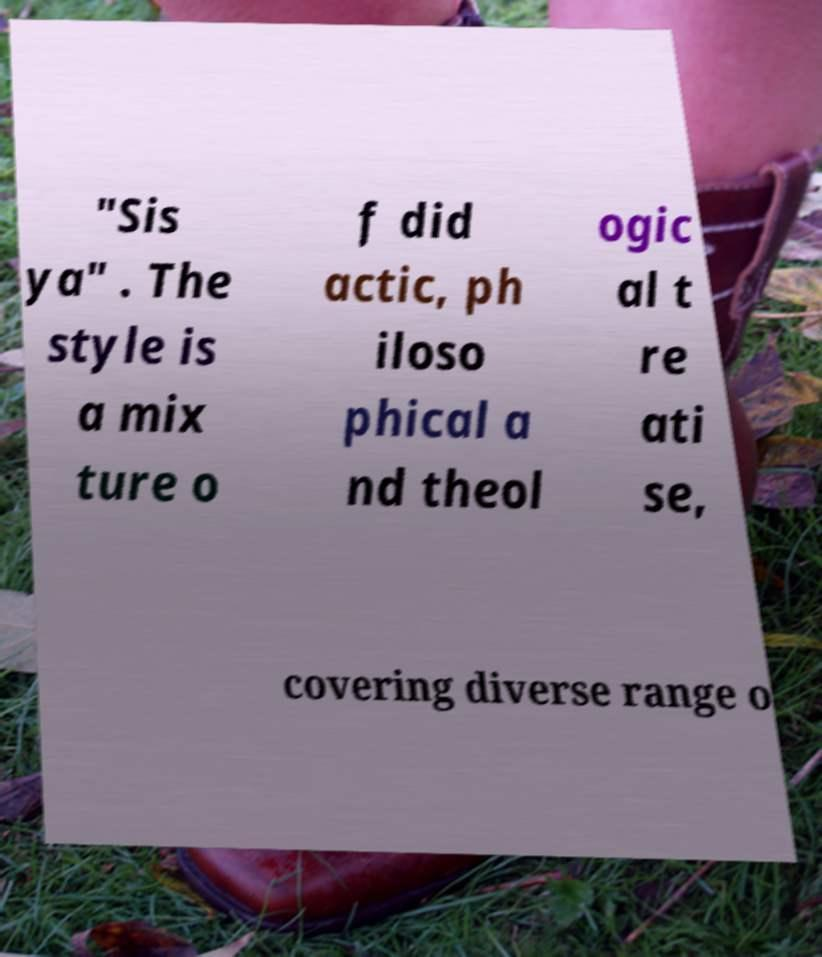Please identify and transcribe the text found in this image. "Sis ya" . The style is a mix ture o f did actic, ph iloso phical a nd theol ogic al t re ati se, covering diverse range o 